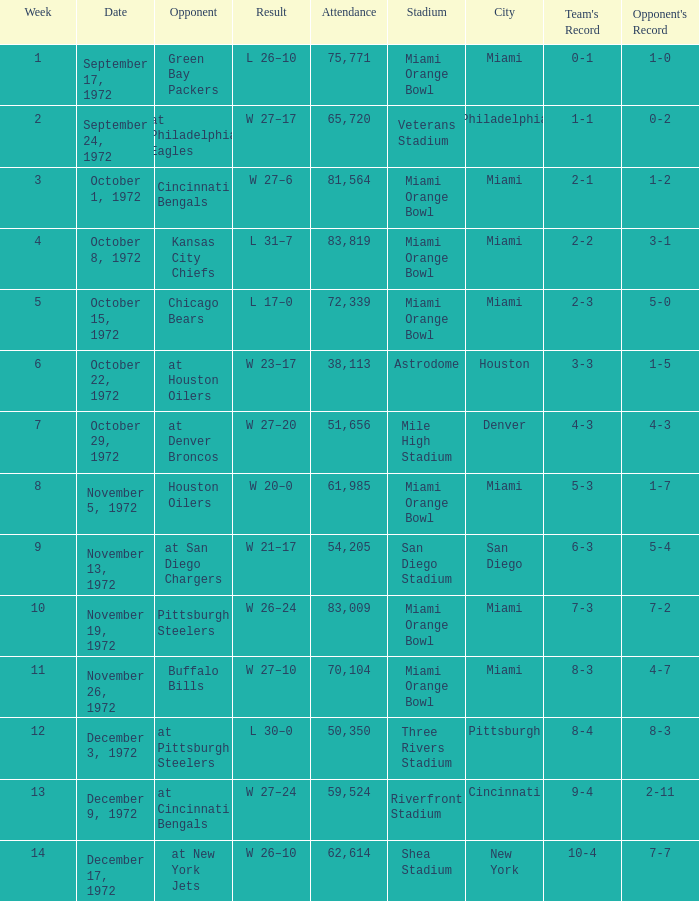What is the sum of week number(s) had an attendance of 61,985? 1.0. 